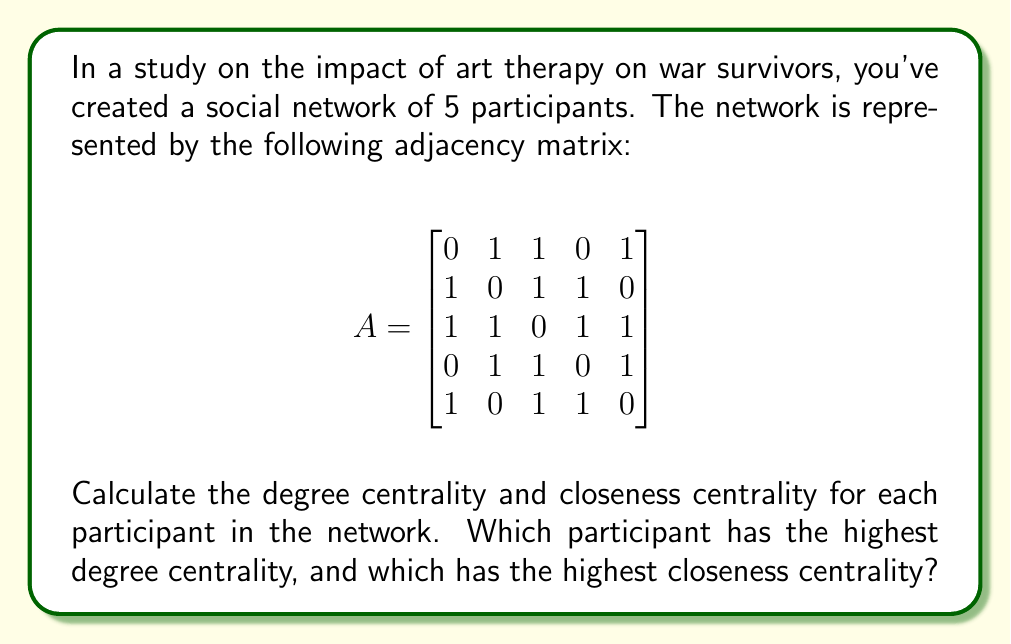Help me with this question. To solve this problem, we need to calculate two centrality measures for each participant:

1. Degree Centrality
2. Closeness Centrality

Step 1: Calculating Degree Centrality

Degree centrality is the number of direct connections a node has. For an undirected graph, it's the sum of each row (or column) in the adjacency matrix.

For each participant:
P1: $1 + 1 + 0 + 1 = 3$
P2: $1 + 1 + 1 + 0 = 3$
P3: $1 + 1 + 1 + 1 = 4$
P4: $0 + 1 + 1 + 1 = 3$
P5: $1 + 0 + 1 + 1 = 3$

Step 2: Calculating Closeness Centrality

Closeness centrality is the reciprocal of the sum of the shortest path distances from a node to all other nodes.

First, we need to calculate the shortest path distances:

[asy]
unitsize(30);
pair[] p = {(0,0), (2,0), (1,1.7), (-1,1.7), (-2,0)};
for(int i=0; i<5; ++i) {
  dot(p[i]);
  label("P"+(string)(i+1), p[i], align=2*unit(p[i]));
}
draw(p[0]--p[1]--p[2]--p[3]--p[4]--p[0]);
draw(p[0]--p[2]);
draw(p[1]--p[3]);
draw(p[2]--p[4]);
[/asy]

Distance matrix:
$$
D = \begin{bmatrix}
0 & 1 & 1 & 2 & 1 \\
1 & 0 & 1 & 1 & 2 \\
1 & 1 & 0 & 1 & 1 \\
2 & 1 & 1 & 0 & 1 \\
1 & 2 & 1 & 1 & 0
\end{bmatrix}
$$

Now, calculate closeness centrality for each participant:

P1: $\frac{1}{1 + 1 + 2 + 1} = \frac{1}{5} = 0.2$
P2: $\frac{1}{1 + 1 + 1 + 2} = \frac{1}{5} = 0.2$
P3: $\frac{1}{1 + 1 + 1 + 1} = \frac{1}{4} = 0.25$
P4: $\frac{1}{2 + 1 + 1 + 1} = \frac{1}{5} = 0.2$
P5: $\frac{1}{1 + 2 + 1 + 1} = \frac{1}{5} = 0.2$
Answer: Degree Centrality:
P1: 3, P2: 3, P3: 4, P4: 3, P5: 3

Closeness Centrality:
P1: 0.2, P2: 0.2, P3: 0.25, P4: 0.2, P5: 0.2

Participant 3 (P3) has both the highest degree centrality (4) and the highest closeness centrality (0.25). 